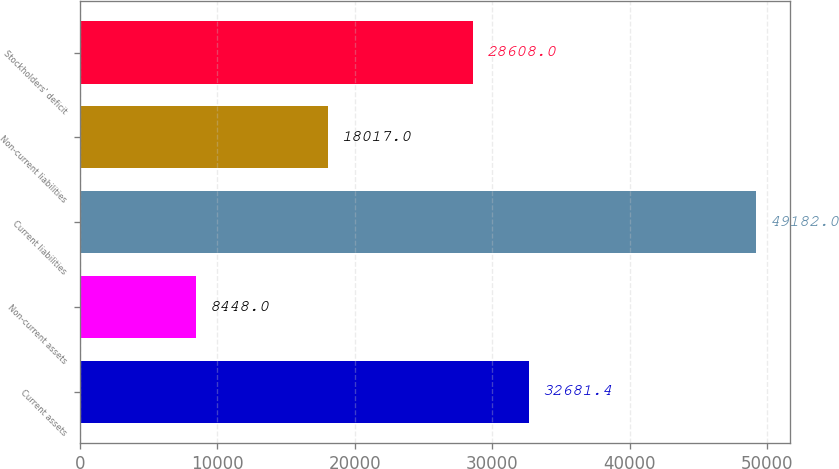Convert chart. <chart><loc_0><loc_0><loc_500><loc_500><bar_chart><fcel>Current assets<fcel>Non-current assets<fcel>Current liabilities<fcel>Non-current liabilities<fcel>Stockholders' deficit<nl><fcel>32681.4<fcel>8448<fcel>49182<fcel>18017<fcel>28608<nl></chart> 